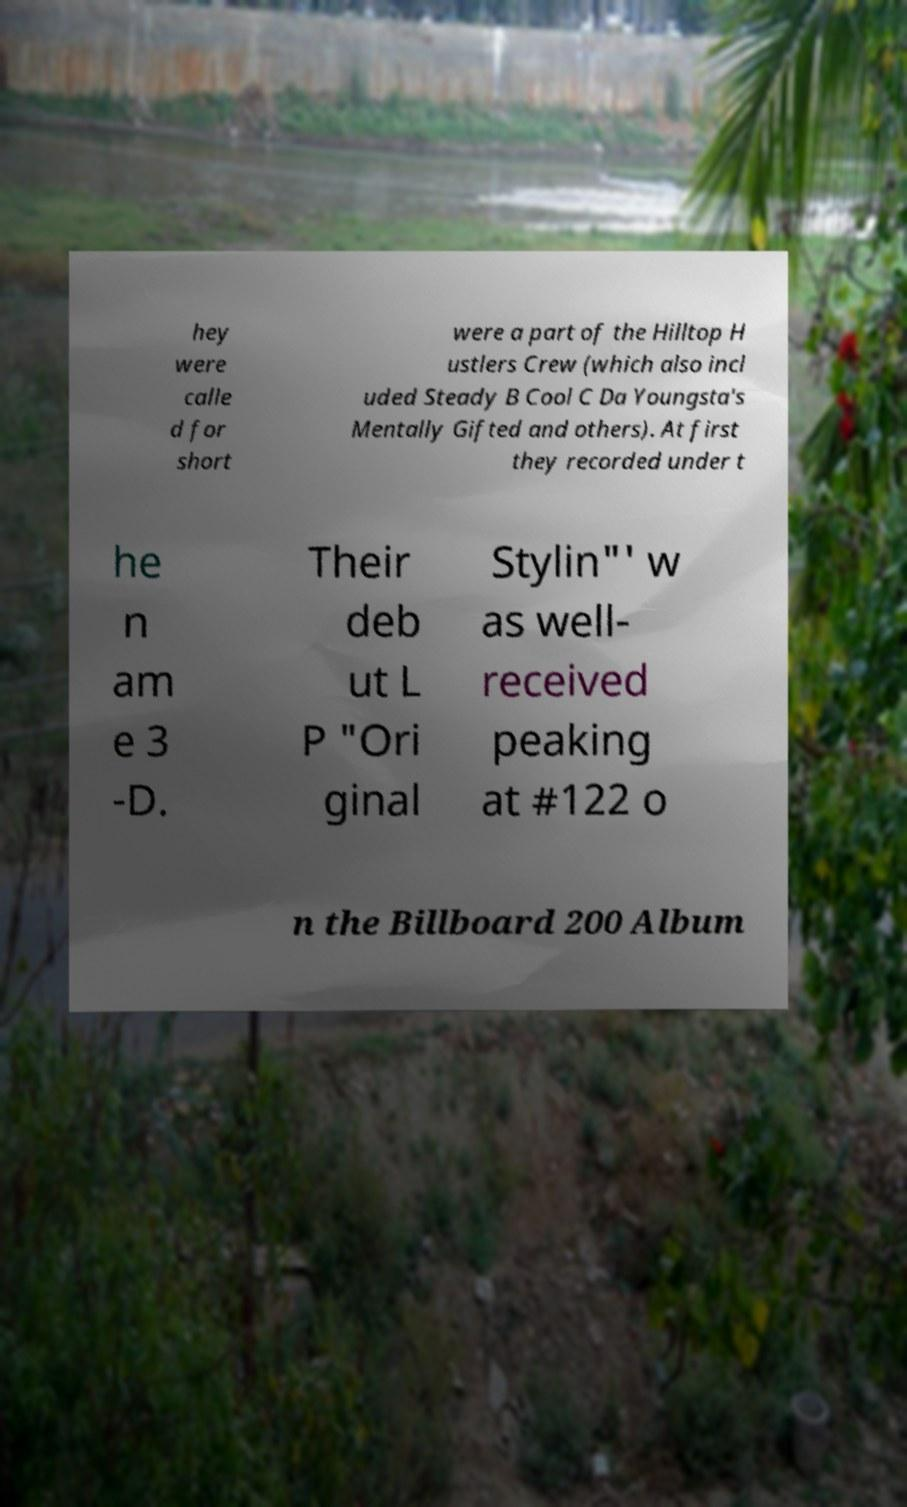Can you accurately transcribe the text from the provided image for me? hey were calle d for short were a part of the Hilltop H ustlers Crew (which also incl uded Steady B Cool C Da Youngsta's Mentally Gifted and others). At first they recorded under t he n am e 3 -D. Their deb ut L P "Ori ginal Stylin"' w as well- received peaking at #122 o n the Billboard 200 Album 